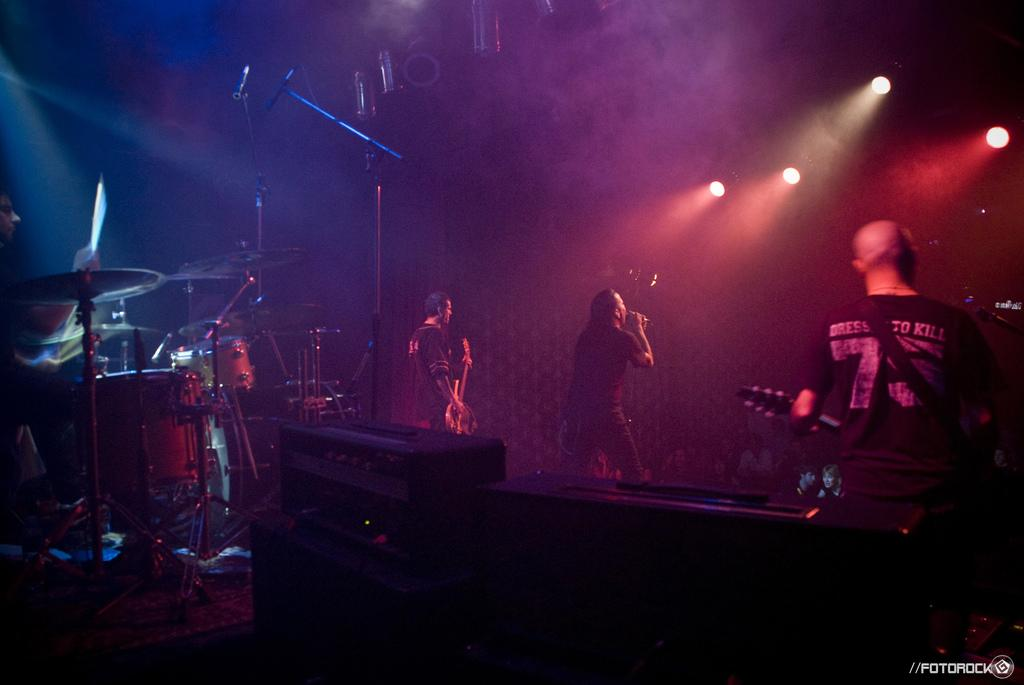How many people are on the stage in the image? There are three people on the stage in the image. What are the people on the stage doing? The people are performing and playing musical instruments. Can you describe the man in the middle? The man in the middle is singing. What else can be seen on the stage? There are musical instruments behind the people. What equipment is used for amplifying the singer's voice? A mic stand is present. How does the porter help the band during the performance in the image? There is no porter present in the image, so it is not possible to answer that question. 